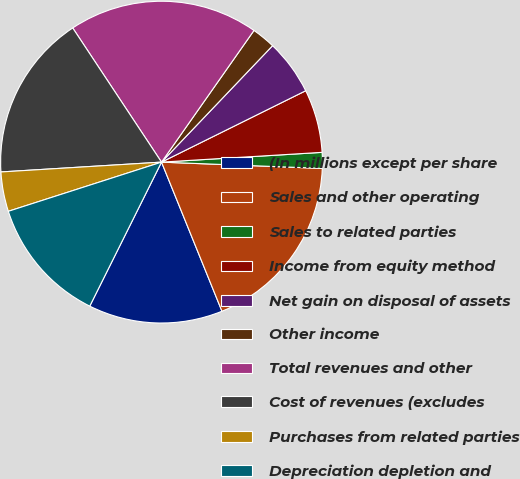Convert chart. <chart><loc_0><loc_0><loc_500><loc_500><pie_chart><fcel>(In millions except per share<fcel>Sales and other operating<fcel>Sales to related parties<fcel>Income from equity method<fcel>Net gain on disposal of assets<fcel>Other income<fcel>Total revenues and other<fcel>Cost of revenues (excludes<fcel>Purchases from related parties<fcel>Depreciation depletion and<nl><fcel>13.49%<fcel>18.25%<fcel>1.59%<fcel>6.35%<fcel>5.56%<fcel>2.38%<fcel>19.05%<fcel>16.67%<fcel>3.97%<fcel>12.7%<nl></chart> 